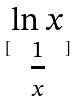Convert formula to latex. <formula><loc_0><loc_0><loc_500><loc_500>[ \begin{matrix} \ln x \\ \frac { 1 } { x } \end{matrix} ]</formula> 